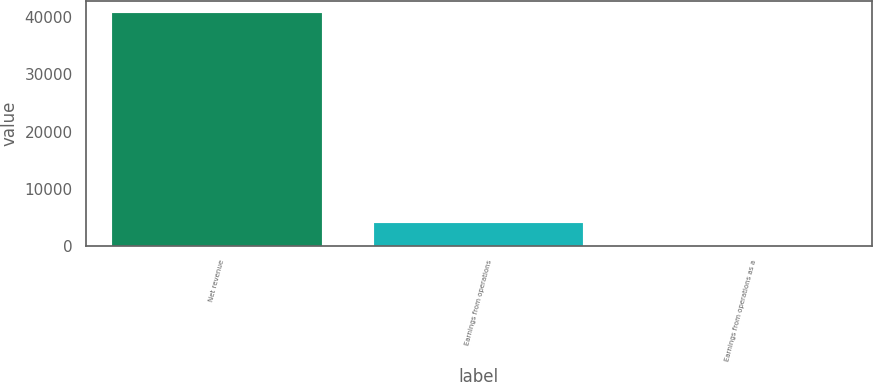Convert chart. <chart><loc_0><loc_0><loc_500><loc_500><bar_chart><fcel>Net revenue<fcel>Earnings from operations<fcel>Earnings from operations as a<nl><fcel>40741<fcel>4078.6<fcel>5<nl></chart> 